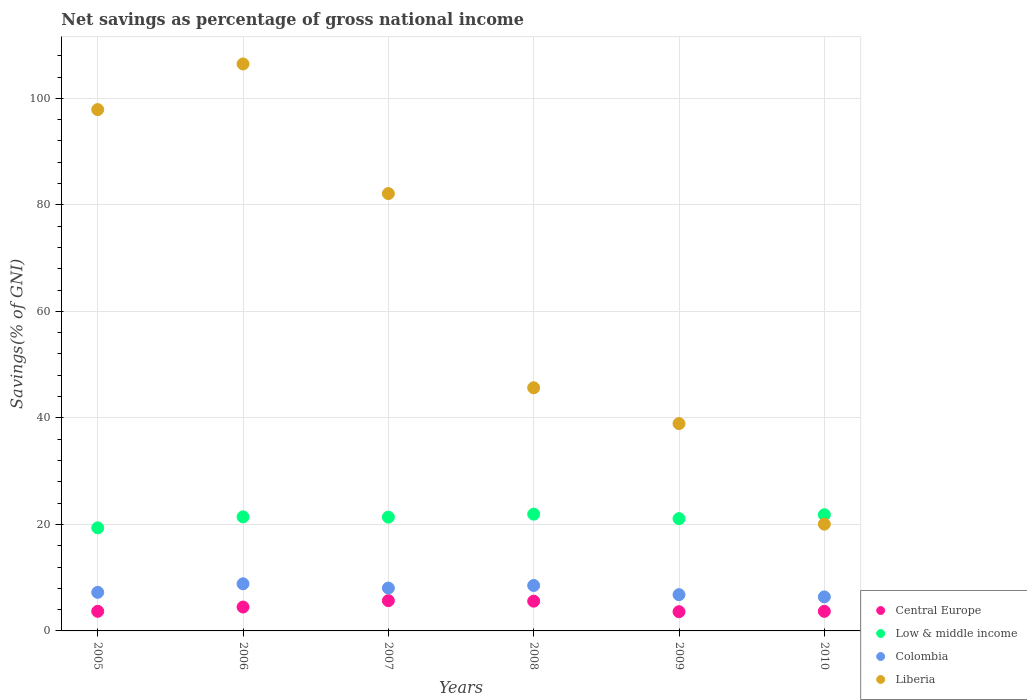Is the number of dotlines equal to the number of legend labels?
Offer a very short reply. Yes. What is the total savings in Liberia in 2010?
Your answer should be very brief. 20.05. Across all years, what is the maximum total savings in Liberia?
Ensure brevity in your answer.  106.46. Across all years, what is the minimum total savings in Low & middle income?
Give a very brief answer. 19.36. What is the total total savings in Liberia in the graph?
Your answer should be compact. 391.12. What is the difference between the total savings in Central Europe in 2005 and that in 2006?
Give a very brief answer. -0.8. What is the difference between the total savings in Central Europe in 2005 and the total savings in Low & middle income in 2009?
Your answer should be compact. -17.4. What is the average total savings in Liberia per year?
Keep it short and to the point. 65.19. In the year 2010, what is the difference between the total savings in Central Europe and total savings in Colombia?
Ensure brevity in your answer.  -2.71. In how many years, is the total savings in Central Europe greater than 56 %?
Make the answer very short. 0. What is the ratio of the total savings in Central Europe in 2005 to that in 2007?
Offer a terse response. 0.65. Is the total savings in Low & middle income in 2007 less than that in 2008?
Offer a very short reply. Yes. Is the difference between the total savings in Central Europe in 2005 and 2009 greater than the difference between the total savings in Colombia in 2005 and 2009?
Keep it short and to the point. No. What is the difference between the highest and the second highest total savings in Central Europe?
Your answer should be very brief. 0.09. What is the difference between the highest and the lowest total savings in Colombia?
Your answer should be compact. 2.46. Is the sum of the total savings in Colombia in 2006 and 2010 greater than the maximum total savings in Central Europe across all years?
Offer a terse response. Yes. Is it the case that in every year, the sum of the total savings in Central Europe and total savings in Colombia  is greater than the total savings in Low & middle income?
Your answer should be very brief. No. What is the difference between two consecutive major ticks on the Y-axis?
Keep it short and to the point. 20. Does the graph contain any zero values?
Make the answer very short. No. How many legend labels are there?
Make the answer very short. 4. How are the legend labels stacked?
Make the answer very short. Vertical. What is the title of the graph?
Your answer should be compact. Net savings as percentage of gross national income. What is the label or title of the X-axis?
Ensure brevity in your answer.  Years. What is the label or title of the Y-axis?
Keep it short and to the point. Savings(% of GNI). What is the Savings(% of GNI) of Central Europe in 2005?
Give a very brief answer. 3.68. What is the Savings(% of GNI) in Low & middle income in 2005?
Provide a short and direct response. 19.36. What is the Savings(% of GNI) of Colombia in 2005?
Provide a short and direct response. 7.24. What is the Savings(% of GNI) of Liberia in 2005?
Give a very brief answer. 97.89. What is the Savings(% of GNI) in Central Europe in 2006?
Provide a short and direct response. 4.48. What is the Savings(% of GNI) in Low & middle income in 2006?
Offer a very short reply. 21.42. What is the Savings(% of GNI) of Colombia in 2006?
Offer a very short reply. 8.85. What is the Savings(% of GNI) in Liberia in 2006?
Make the answer very short. 106.46. What is the Savings(% of GNI) of Central Europe in 2007?
Your answer should be very brief. 5.68. What is the Savings(% of GNI) of Low & middle income in 2007?
Make the answer very short. 21.36. What is the Savings(% of GNI) in Colombia in 2007?
Your answer should be very brief. 8.05. What is the Savings(% of GNI) in Liberia in 2007?
Make the answer very short. 82.12. What is the Savings(% of GNI) of Central Europe in 2008?
Keep it short and to the point. 5.59. What is the Savings(% of GNI) in Low & middle income in 2008?
Your answer should be very brief. 21.93. What is the Savings(% of GNI) in Colombia in 2008?
Ensure brevity in your answer.  8.53. What is the Savings(% of GNI) in Liberia in 2008?
Ensure brevity in your answer.  45.66. What is the Savings(% of GNI) of Central Europe in 2009?
Your answer should be very brief. 3.61. What is the Savings(% of GNI) of Low & middle income in 2009?
Keep it short and to the point. 21.09. What is the Savings(% of GNI) of Colombia in 2009?
Ensure brevity in your answer.  6.81. What is the Savings(% of GNI) in Liberia in 2009?
Provide a succinct answer. 38.93. What is the Savings(% of GNI) in Central Europe in 2010?
Offer a terse response. 3.68. What is the Savings(% of GNI) of Low & middle income in 2010?
Offer a terse response. 21.82. What is the Savings(% of GNI) of Colombia in 2010?
Your answer should be compact. 6.39. What is the Savings(% of GNI) of Liberia in 2010?
Ensure brevity in your answer.  20.05. Across all years, what is the maximum Savings(% of GNI) of Central Europe?
Provide a succinct answer. 5.68. Across all years, what is the maximum Savings(% of GNI) in Low & middle income?
Offer a terse response. 21.93. Across all years, what is the maximum Savings(% of GNI) of Colombia?
Your answer should be compact. 8.85. Across all years, what is the maximum Savings(% of GNI) of Liberia?
Offer a terse response. 106.46. Across all years, what is the minimum Savings(% of GNI) of Central Europe?
Provide a short and direct response. 3.61. Across all years, what is the minimum Savings(% of GNI) in Low & middle income?
Ensure brevity in your answer.  19.36. Across all years, what is the minimum Savings(% of GNI) of Colombia?
Provide a succinct answer. 6.39. Across all years, what is the minimum Savings(% of GNI) in Liberia?
Give a very brief answer. 20.05. What is the total Savings(% of GNI) of Central Europe in the graph?
Make the answer very short. 26.72. What is the total Savings(% of GNI) of Low & middle income in the graph?
Offer a very short reply. 126.96. What is the total Savings(% of GNI) in Colombia in the graph?
Make the answer very short. 45.87. What is the total Savings(% of GNI) of Liberia in the graph?
Provide a succinct answer. 391.12. What is the difference between the Savings(% of GNI) in Central Europe in 2005 and that in 2006?
Keep it short and to the point. -0.8. What is the difference between the Savings(% of GNI) of Low & middle income in 2005 and that in 2006?
Provide a succinct answer. -2.06. What is the difference between the Savings(% of GNI) of Colombia in 2005 and that in 2006?
Make the answer very short. -1.61. What is the difference between the Savings(% of GNI) in Liberia in 2005 and that in 2006?
Make the answer very short. -8.57. What is the difference between the Savings(% of GNI) of Central Europe in 2005 and that in 2007?
Offer a terse response. -2. What is the difference between the Savings(% of GNI) in Low & middle income in 2005 and that in 2007?
Offer a terse response. -2.01. What is the difference between the Savings(% of GNI) of Colombia in 2005 and that in 2007?
Ensure brevity in your answer.  -0.8. What is the difference between the Savings(% of GNI) of Liberia in 2005 and that in 2007?
Your answer should be very brief. 15.77. What is the difference between the Savings(% of GNI) in Central Europe in 2005 and that in 2008?
Provide a short and direct response. -1.9. What is the difference between the Savings(% of GNI) in Low & middle income in 2005 and that in 2008?
Make the answer very short. -2.57. What is the difference between the Savings(% of GNI) of Colombia in 2005 and that in 2008?
Offer a terse response. -1.29. What is the difference between the Savings(% of GNI) of Liberia in 2005 and that in 2008?
Give a very brief answer. 52.24. What is the difference between the Savings(% of GNI) in Central Europe in 2005 and that in 2009?
Offer a very short reply. 0.07. What is the difference between the Savings(% of GNI) of Low & middle income in 2005 and that in 2009?
Your answer should be compact. -1.73. What is the difference between the Savings(% of GNI) of Colombia in 2005 and that in 2009?
Provide a short and direct response. 0.43. What is the difference between the Savings(% of GNI) in Liberia in 2005 and that in 2009?
Your answer should be compact. 58.96. What is the difference between the Savings(% of GNI) in Central Europe in 2005 and that in 2010?
Provide a succinct answer. 0. What is the difference between the Savings(% of GNI) in Low & middle income in 2005 and that in 2010?
Ensure brevity in your answer.  -2.46. What is the difference between the Savings(% of GNI) of Colombia in 2005 and that in 2010?
Offer a terse response. 0.85. What is the difference between the Savings(% of GNI) in Liberia in 2005 and that in 2010?
Provide a succinct answer. 77.84. What is the difference between the Savings(% of GNI) in Central Europe in 2006 and that in 2007?
Offer a terse response. -1.2. What is the difference between the Savings(% of GNI) of Low & middle income in 2006 and that in 2007?
Offer a very short reply. 0.05. What is the difference between the Savings(% of GNI) in Colombia in 2006 and that in 2007?
Make the answer very short. 0.8. What is the difference between the Savings(% of GNI) of Liberia in 2006 and that in 2007?
Your answer should be compact. 24.34. What is the difference between the Savings(% of GNI) of Central Europe in 2006 and that in 2008?
Provide a succinct answer. -1.1. What is the difference between the Savings(% of GNI) in Low & middle income in 2006 and that in 2008?
Provide a succinct answer. -0.51. What is the difference between the Savings(% of GNI) in Colombia in 2006 and that in 2008?
Your answer should be compact. 0.31. What is the difference between the Savings(% of GNI) in Liberia in 2006 and that in 2008?
Provide a short and direct response. 60.81. What is the difference between the Savings(% of GNI) in Central Europe in 2006 and that in 2009?
Offer a terse response. 0.88. What is the difference between the Savings(% of GNI) in Low & middle income in 2006 and that in 2009?
Your answer should be very brief. 0.33. What is the difference between the Savings(% of GNI) in Colombia in 2006 and that in 2009?
Make the answer very short. 2.04. What is the difference between the Savings(% of GNI) of Liberia in 2006 and that in 2009?
Make the answer very short. 67.53. What is the difference between the Savings(% of GNI) of Central Europe in 2006 and that in 2010?
Offer a terse response. 0.81. What is the difference between the Savings(% of GNI) of Low & middle income in 2006 and that in 2010?
Your answer should be very brief. -0.4. What is the difference between the Savings(% of GNI) of Colombia in 2006 and that in 2010?
Provide a succinct answer. 2.46. What is the difference between the Savings(% of GNI) in Liberia in 2006 and that in 2010?
Your response must be concise. 86.41. What is the difference between the Savings(% of GNI) in Central Europe in 2007 and that in 2008?
Offer a very short reply. 0.09. What is the difference between the Savings(% of GNI) in Low & middle income in 2007 and that in 2008?
Provide a succinct answer. -0.56. What is the difference between the Savings(% of GNI) in Colombia in 2007 and that in 2008?
Make the answer very short. -0.49. What is the difference between the Savings(% of GNI) of Liberia in 2007 and that in 2008?
Keep it short and to the point. 36.46. What is the difference between the Savings(% of GNI) of Central Europe in 2007 and that in 2009?
Your response must be concise. 2.07. What is the difference between the Savings(% of GNI) of Low & middle income in 2007 and that in 2009?
Your answer should be very brief. 0.28. What is the difference between the Savings(% of GNI) in Colombia in 2007 and that in 2009?
Your answer should be very brief. 1.24. What is the difference between the Savings(% of GNI) in Liberia in 2007 and that in 2009?
Make the answer very short. 43.19. What is the difference between the Savings(% of GNI) in Central Europe in 2007 and that in 2010?
Provide a succinct answer. 2. What is the difference between the Savings(% of GNI) in Low & middle income in 2007 and that in 2010?
Make the answer very short. -0.45. What is the difference between the Savings(% of GNI) in Colombia in 2007 and that in 2010?
Make the answer very short. 1.66. What is the difference between the Savings(% of GNI) of Liberia in 2007 and that in 2010?
Provide a short and direct response. 62.07. What is the difference between the Savings(% of GNI) in Central Europe in 2008 and that in 2009?
Keep it short and to the point. 1.98. What is the difference between the Savings(% of GNI) in Low & middle income in 2008 and that in 2009?
Keep it short and to the point. 0.84. What is the difference between the Savings(% of GNI) of Colombia in 2008 and that in 2009?
Your answer should be very brief. 1.73. What is the difference between the Savings(% of GNI) in Liberia in 2008 and that in 2009?
Offer a terse response. 6.73. What is the difference between the Savings(% of GNI) in Central Europe in 2008 and that in 2010?
Ensure brevity in your answer.  1.91. What is the difference between the Savings(% of GNI) of Low & middle income in 2008 and that in 2010?
Offer a very short reply. 0.11. What is the difference between the Savings(% of GNI) in Colombia in 2008 and that in 2010?
Your answer should be compact. 2.14. What is the difference between the Savings(% of GNI) of Liberia in 2008 and that in 2010?
Give a very brief answer. 25.61. What is the difference between the Savings(% of GNI) in Central Europe in 2009 and that in 2010?
Provide a succinct answer. -0.07. What is the difference between the Savings(% of GNI) of Low & middle income in 2009 and that in 2010?
Your answer should be compact. -0.73. What is the difference between the Savings(% of GNI) of Colombia in 2009 and that in 2010?
Offer a terse response. 0.42. What is the difference between the Savings(% of GNI) of Liberia in 2009 and that in 2010?
Make the answer very short. 18.88. What is the difference between the Savings(% of GNI) in Central Europe in 2005 and the Savings(% of GNI) in Low & middle income in 2006?
Provide a succinct answer. -17.74. What is the difference between the Savings(% of GNI) in Central Europe in 2005 and the Savings(% of GNI) in Colombia in 2006?
Ensure brevity in your answer.  -5.17. What is the difference between the Savings(% of GNI) of Central Europe in 2005 and the Savings(% of GNI) of Liberia in 2006?
Offer a very short reply. -102.78. What is the difference between the Savings(% of GNI) in Low & middle income in 2005 and the Savings(% of GNI) in Colombia in 2006?
Offer a very short reply. 10.51. What is the difference between the Savings(% of GNI) in Low & middle income in 2005 and the Savings(% of GNI) in Liberia in 2006?
Give a very brief answer. -87.11. What is the difference between the Savings(% of GNI) of Colombia in 2005 and the Savings(% of GNI) of Liberia in 2006?
Provide a succinct answer. -99.22. What is the difference between the Savings(% of GNI) in Central Europe in 2005 and the Savings(% of GNI) in Low & middle income in 2007?
Offer a terse response. -17.68. What is the difference between the Savings(% of GNI) in Central Europe in 2005 and the Savings(% of GNI) in Colombia in 2007?
Give a very brief answer. -4.37. What is the difference between the Savings(% of GNI) of Central Europe in 2005 and the Savings(% of GNI) of Liberia in 2007?
Offer a very short reply. -78.44. What is the difference between the Savings(% of GNI) in Low & middle income in 2005 and the Savings(% of GNI) in Colombia in 2007?
Ensure brevity in your answer.  11.31. What is the difference between the Savings(% of GNI) in Low & middle income in 2005 and the Savings(% of GNI) in Liberia in 2007?
Your answer should be very brief. -62.76. What is the difference between the Savings(% of GNI) in Colombia in 2005 and the Savings(% of GNI) in Liberia in 2007?
Offer a terse response. -74.88. What is the difference between the Savings(% of GNI) in Central Europe in 2005 and the Savings(% of GNI) in Low & middle income in 2008?
Give a very brief answer. -18.24. What is the difference between the Savings(% of GNI) in Central Europe in 2005 and the Savings(% of GNI) in Colombia in 2008?
Offer a terse response. -4.85. What is the difference between the Savings(% of GNI) in Central Europe in 2005 and the Savings(% of GNI) in Liberia in 2008?
Provide a short and direct response. -41.98. What is the difference between the Savings(% of GNI) of Low & middle income in 2005 and the Savings(% of GNI) of Colombia in 2008?
Offer a very short reply. 10.82. What is the difference between the Savings(% of GNI) in Low & middle income in 2005 and the Savings(% of GNI) in Liberia in 2008?
Your answer should be very brief. -26.3. What is the difference between the Savings(% of GNI) in Colombia in 2005 and the Savings(% of GNI) in Liberia in 2008?
Offer a terse response. -38.42. What is the difference between the Savings(% of GNI) in Central Europe in 2005 and the Savings(% of GNI) in Low & middle income in 2009?
Offer a very short reply. -17.4. What is the difference between the Savings(% of GNI) of Central Europe in 2005 and the Savings(% of GNI) of Colombia in 2009?
Your answer should be very brief. -3.13. What is the difference between the Savings(% of GNI) of Central Europe in 2005 and the Savings(% of GNI) of Liberia in 2009?
Make the answer very short. -35.25. What is the difference between the Savings(% of GNI) in Low & middle income in 2005 and the Savings(% of GNI) in Colombia in 2009?
Offer a terse response. 12.55. What is the difference between the Savings(% of GNI) in Low & middle income in 2005 and the Savings(% of GNI) in Liberia in 2009?
Provide a succinct answer. -19.58. What is the difference between the Savings(% of GNI) of Colombia in 2005 and the Savings(% of GNI) of Liberia in 2009?
Provide a succinct answer. -31.69. What is the difference between the Savings(% of GNI) in Central Europe in 2005 and the Savings(% of GNI) in Low & middle income in 2010?
Give a very brief answer. -18.14. What is the difference between the Savings(% of GNI) in Central Europe in 2005 and the Savings(% of GNI) in Colombia in 2010?
Make the answer very short. -2.71. What is the difference between the Savings(% of GNI) in Central Europe in 2005 and the Savings(% of GNI) in Liberia in 2010?
Your answer should be compact. -16.37. What is the difference between the Savings(% of GNI) in Low & middle income in 2005 and the Savings(% of GNI) in Colombia in 2010?
Your answer should be very brief. 12.97. What is the difference between the Savings(% of GNI) of Low & middle income in 2005 and the Savings(% of GNI) of Liberia in 2010?
Provide a succinct answer. -0.69. What is the difference between the Savings(% of GNI) in Colombia in 2005 and the Savings(% of GNI) in Liberia in 2010?
Keep it short and to the point. -12.81. What is the difference between the Savings(% of GNI) of Central Europe in 2006 and the Savings(% of GNI) of Low & middle income in 2007?
Your response must be concise. -16.88. What is the difference between the Savings(% of GNI) of Central Europe in 2006 and the Savings(% of GNI) of Colombia in 2007?
Keep it short and to the point. -3.56. What is the difference between the Savings(% of GNI) in Central Europe in 2006 and the Savings(% of GNI) in Liberia in 2007?
Your response must be concise. -77.64. What is the difference between the Savings(% of GNI) in Low & middle income in 2006 and the Savings(% of GNI) in Colombia in 2007?
Offer a very short reply. 13.37. What is the difference between the Savings(% of GNI) in Low & middle income in 2006 and the Savings(% of GNI) in Liberia in 2007?
Give a very brief answer. -60.7. What is the difference between the Savings(% of GNI) of Colombia in 2006 and the Savings(% of GNI) of Liberia in 2007?
Your answer should be very brief. -73.27. What is the difference between the Savings(% of GNI) of Central Europe in 2006 and the Savings(% of GNI) of Low & middle income in 2008?
Offer a very short reply. -17.44. What is the difference between the Savings(% of GNI) of Central Europe in 2006 and the Savings(% of GNI) of Colombia in 2008?
Your answer should be compact. -4.05. What is the difference between the Savings(% of GNI) in Central Europe in 2006 and the Savings(% of GNI) in Liberia in 2008?
Ensure brevity in your answer.  -41.17. What is the difference between the Savings(% of GNI) of Low & middle income in 2006 and the Savings(% of GNI) of Colombia in 2008?
Offer a very short reply. 12.88. What is the difference between the Savings(% of GNI) in Low & middle income in 2006 and the Savings(% of GNI) in Liberia in 2008?
Your response must be concise. -24.24. What is the difference between the Savings(% of GNI) in Colombia in 2006 and the Savings(% of GNI) in Liberia in 2008?
Your response must be concise. -36.81. What is the difference between the Savings(% of GNI) in Central Europe in 2006 and the Savings(% of GNI) in Low & middle income in 2009?
Provide a succinct answer. -16.6. What is the difference between the Savings(% of GNI) in Central Europe in 2006 and the Savings(% of GNI) in Colombia in 2009?
Your response must be concise. -2.32. What is the difference between the Savings(% of GNI) in Central Europe in 2006 and the Savings(% of GNI) in Liberia in 2009?
Give a very brief answer. -34.45. What is the difference between the Savings(% of GNI) of Low & middle income in 2006 and the Savings(% of GNI) of Colombia in 2009?
Offer a very short reply. 14.61. What is the difference between the Savings(% of GNI) of Low & middle income in 2006 and the Savings(% of GNI) of Liberia in 2009?
Make the answer very short. -17.51. What is the difference between the Savings(% of GNI) in Colombia in 2006 and the Savings(% of GNI) in Liberia in 2009?
Your answer should be compact. -30.08. What is the difference between the Savings(% of GNI) in Central Europe in 2006 and the Savings(% of GNI) in Low & middle income in 2010?
Ensure brevity in your answer.  -17.33. What is the difference between the Savings(% of GNI) in Central Europe in 2006 and the Savings(% of GNI) in Colombia in 2010?
Ensure brevity in your answer.  -1.91. What is the difference between the Savings(% of GNI) in Central Europe in 2006 and the Savings(% of GNI) in Liberia in 2010?
Provide a succinct answer. -15.57. What is the difference between the Savings(% of GNI) of Low & middle income in 2006 and the Savings(% of GNI) of Colombia in 2010?
Ensure brevity in your answer.  15.03. What is the difference between the Savings(% of GNI) in Low & middle income in 2006 and the Savings(% of GNI) in Liberia in 2010?
Keep it short and to the point. 1.37. What is the difference between the Savings(% of GNI) of Colombia in 2006 and the Savings(% of GNI) of Liberia in 2010?
Offer a very short reply. -11.2. What is the difference between the Savings(% of GNI) in Central Europe in 2007 and the Savings(% of GNI) in Low & middle income in 2008?
Ensure brevity in your answer.  -16.24. What is the difference between the Savings(% of GNI) of Central Europe in 2007 and the Savings(% of GNI) of Colombia in 2008?
Your response must be concise. -2.85. What is the difference between the Savings(% of GNI) in Central Europe in 2007 and the Savings(% of GNI) in Liberia in 2008?
Offer a terse response. -39.98. What is the difference between the Savings(% of GNI) in Low & middle income in 2007 and the Savings(% of GNI) in Colombia in 2008?
Your answer should be very brief. 12.83. What is the difference between the Savings(% of GNI) of Low & middle income in 2007 and the Savings(% of GNI) of Liberia in 2008?
Ensure brevity in your answer.  -24.29. What is the difference between the Savings(% of GNI) in Colombia in 2007 and the Savings(% of GNI) in Liberia in 2008?
Ensure brevity in your answer.  -37.61. What is the difference between the Savings(% of GNI) of Central Europe in 2007 and the Savings(% of GNI) of Low & middle income in 2009?
Keep it short and to the point. -15.4. What is the difference between the Savings(% of GNI) in Central Europe in 2007 and the Savings(% of GNI) in Colombia in 2009?
Ensure brevity in your answer.  -1.13. What is the difference between the Savings(% of GNI) of Central Europe in 2007 and the Savings(% of GNI) of Liberia in 2009?
Your response must be concise. -33.25. What is the difference between the Savings(% of GNI) in Low & middle income in 2007 and the Savings(% of GNI) in Colombia in 2009?
Offer a terse response. 14.56. What is the difference between the Savings(% of GNI) in Low & middle income in 2007 and the Savings(% of GNI) in Liberia in 2009?
Provide a succinct answer. -17.57. What is the difference between the Savings(% of GNI) in Colombia in 2007 and the Savings(% of GNI) in Liberia in 2009?
Your answer should be very brief. -30.89. What is the difference between the Savings(% of GNI) in Central Europe in 2007 and the Savings(% of GNI) in Low & middle income in 2010?
Ensure brevity in your answer.  -16.14. What is the difference between the Savings(% of GNI) in Central Europe in 2007 and the Savings(% of GNI) in Colombia in 2010?
Give a very brief answer. -0.71. What is the difference between the Savings(% of GNI) in Central Europe in 2007 and the Savings(% of GNI) in Liberia in 2010?
Offer a terse response. -14.37. What is the difference between the Savings(% of GNI) of Low & middle income in 2007 and the Savings(% of GNI) of Colombia in 2010?
Make the answer very short. 14.97. What is the difference between the Savings(% of GNI) of Low & middle income in 2007 and the Savings(% of GNI) of Liberia in 2010?
Your answer should be very brief. 1.31. What is the difference between the Savings(% of GNI) of Colombia in 2007 and the Savings(% of GNI) of Liberia in 2010?
Your answer should be compact. -12. What is the difference between the Savings(% of GNI) in Central Europe in 2008 and the Savings(% of GNI) in Low & middle income in 2009?
Offer a terse response. -15.5. What is the difference between the Savings(% of GNI) of Central Europe in 2008 and the Savings(% of GNI) of Colombia in 2009?
Provide a short and direct response. -1.22. What is the difference between the Savings(% of GNI) in Central Europe in 2008 and the Savings(% of GNI) in Liberia in 2009?
Offer a terse response. -33.35. What is the difference between the Savings(% of GNI) of Low & middle income in 2008 and the Savings(% of GNI) of Colombia in 2009?
Ensure brevity in your answer.  15.12. What is the difference between the Savings(% of GNI) of Low & middle income in 2008 and the Savings(% of GNI) of Liberia in 2009?
Your answer should be very brief. -17.01. What is the difference between the Savings(% of GNI) of Colombia in 2008 and the Savings(% of GNI) of Liberia in 2009?
Your answer should be very brief. -30.4. What is the difference between the Savings(% of GNI) in Central Europe in 2008 and the Savings(% of GNI) in Low & middle income in 2010?
Your response must be concise. -16.23. What is the difference between the Savings(% of GNI) of Central Europe in 2008 and the Savings(% of GNI) of Colombia in 2010?
Your answer should be very brief. -0.81. What is the difference between the Savings(% of GNI) in Central Europe in 2008 and the Savings(% of GNI) in Liberia in 2010?
Offer a terse response. -14.46. What is the difference between the Savings(% of GNI) in Low & middle income in 2008 and the Savings(% of GNI) in Colombia in 2010?
Provide a succinct answer. 15.53. What is the difference between the Savings(% of GNI) of Low & middle income in 2008 and the Savings(% of GNI) of Liberia in 2010?
Provide a succinct answer. 1.87. What is the difference between the Savings(% of GNI) of Colombia in 2008 and the Savings(% of GNI) of Liberia in 2010?
Ensure brevity in your answer.  -11.52. What is the difference between the Savings(% of GNI) of Central Europe in 2009 and the Savings(% of GNI) of Low & middle income in 2010?
Offer a very short reply. -18.21. What is the difference between the Savings(% of GNI) in Central Europe in 2009 and the Savings(% of GNI) in Colombia in 2010?
Offer a very short reply. -2.78. What is the difference between the Savings(% of GNI) in Central Europe in 2009 and the Savings(% of GNI) in Liberia in 2010?
Ensure brevity in your answer.  -16.44. What is the difference between the Savings(% of GNI) of Low & middle income in 2009 and the Savings(% of GNI) of Colombia in 2010?
Ensure brevity in your answer.  14.69. What is the difference between the Savings(% of GNI) in Low & middle income in 2009 and the Savings(% of GNI) in Liberia in 2010?
Ensure brevity in your answer.  1.03. What is the difference between the Savings(% of GNI) of Colombia in 2009 and the Savings(% of GNI) of Liberia in 2010?
Your response must be concise. -13.24. What is the average Savings(% of GNI) in Central Europe per year?
Make the answer very short. 4.45. What is the average Savings(% of GNI) of Low & middle income per year?
Your answer should be very brief. 21.16. What is the average Savings(% of GNI) in Colombia per year?
Provide a succinct answer. 7.64. What is the average Savings(% of GNI) in Liberia per year?
Offer a very short reply. 65.19. In the year 2005, what is the difference between the Savings(% of GNI) in Central Europe and Savings(% of GNI) in Low & middle income?
Make the answer very short. -15.68. In the year 2005, what is the difference between the Savings(% of GNI) of Central Europe and Savings(% of GNI) of Colombia?
Ensure brevity in your answer.  -3.56. In the year 2005, what is the difference between the Savings(% of GNI) of Central Europe and Savings(% of GNI) of Liberia?
Give a very brief answer. -94.21. In the year 2005, what is the difference between the Savings(% of GNI) of Low & middle income and Savings(% of GNI) of Colombia?
Ensure brevity in your answer.  12.11. In the year 2005, what is the difference between the Savings(% of GNI) of Low & middle income and Savings(% of GNI) of Liberia?
Your response must be concise. -78.54. In the year 2005, what is the difference between the Savings(% of GNI) in Colombia and Savings(% of GNI) in Liberia?
Your answer should be compact. -90.65. In the year 2006, what is the difference between the Savings(% of GNI) in Central Europe and Savings(% of GNI) in Low & middle income?
Your answer should be very brief. -16.93. In the year 2006, what is the difference between the Savings(% of GNI) in Central Europe and Savings(% of GNI) in Colombia?
Provide a short and direct response. -4.36. In the year 2006, what is the difference between the Savings(% of GNI) in Central Europe and Savings(% of GNI) in Liberia?
Make the answer very short. -101.98. In the year 2006, what is the difference between the Savings(% of GNI) of Low & middle income and Savings(% of GNI) of Colombia?
Ensure brevity in your answer.  12.57. In the year 2006, what is the difference between the Savings(% of GNI) in Low & middle income and Savings(% of GNI) in Liberia?
Ensure brevity in your answer.  -85.05. In the year 2006, what is the difference between the Savings(% of GNI) in Colombia and Savings(% of GNI) in Liberia?
Give a very brief answer. -97.61. In the year 2007, what is the difference between the Savings(% of GNI) of Central Europe and Savings(% of GNI) of Low & middle income?
Offer a very short reply. -15.68. In the year 2007, what is the difference between the Savings(% of GNI) in Central Europe and Savings(% of GNI) in Colombia?
Offer a very short reply. -2.37. In the year 2007, what is the difference between the Savings(% of GNI) in Central Europe and Savings(% of GNI) in Liberia?
Give a very brief answer. -76.44. In the year 2007, what is the difference between the Savings(% of GNI) in Low & middle income and Savings(% of GNI) in Colombia?
Offer a terse response. 13.32. In the year 2007, what is the difference between the Savings(% of GNI) in Low & middle income and Savings(% of GNI) in Liberia?
Ensure brevity in your answer.  -60.76. In the year 2007, what is the difference between the Savings(% of GNI) in Colombia and Savings(% of GNI) in Liberia?
Give a very brief answer. -74.07. In the year 2008, what is the difference between the Savings(% of GNI) in Central Europe and Savings(% of GNI) in Low & middle income?
Your answer should be very brief. -16.34. In the year 2008, what is the difference between the Savings(% of GNI) in Central Europe and Savings(% of GNI) in Colombia?
Keep it short and to the point. -2.95. In the year 2008, what is the difference between the Savings(% of GNI) of Central Europe and Savings(% of GNI) of Liberia?
Keep it short and to the point. -40.07. In the year 2008, what is the difference between the Savings(% of GNI) of Low & middle income and Savings(% of GNI) of Colombia?
Keep it short and to the point. 13.39. In the year 2008, what is the difference between the Savings(% of GNI) in Low & middle income and Savings(% of GNI) in Liberia?
Provide a short and direct response. -23.73. In the year 2008, what is the difference between the Savings(% of GNI) in Colombia and Savings(% of GNI) in Liberia?
Your response must be concise. -37.12. In the year 2009, what is the difference between the Savings(% of GNI) in Central Europe and Savings(% of GNI) in Low & middle income?
Your response must be concise. -17.48. In the year 2009, what is the difference between the Savings(% of GNI) in Central Europe and Savings(% of GNI) in Colombia?
Offer a terse response. -3.2. In the year 2009, what is the difference between the Savings(% of GNI) of Central Europe and Savings(% of GNI) of Liberia?
Make the answer very short. -35.32. In the year 2009, what is the difference between the Savings(% of GNI) of Low & middle income and Savings(% of GNI) of Colombia?
Your response must be concise. 14.28. In the year 2009, what is the difference between the Savings(% of GNI) in Low & middle income and Savings(% of GNI) in Liberia?
Ensure brevity in your answer.  -17.85. In the year 2009, what is the difference between the Savings(% of GNI) in Colombia and Savings(% of GNI) in Liberia?
Provide a short and direct response. -32.12. In the year 2010, what is the difference between the Savings(% of GNI) in Central Europe and Savings(% of GNI) in Low & middle income?
Ensure brevity in your answer.  -18.14. In the year 2010, what is the difference between the Savings(% of GNI) of Central Europe and Savings(% of GNI) of Colombia?
Make the answer very short. -2.71. In the year 2010, what is the difference between the Savings(% of GNI) in Central Europe and Savings(% of GNI) in Liberia?
Your answer should be compact. -16.37. In the year 2010, what is the difference between the Savings(% of GNI) in Low & middle income and Savings(% of GNI) in Colombia?
Ensure brevity in your answer.  15.43. In the year 2010, what is the difference between the Savings(% of GNI) of Low & middle income and Savings(% of GNI) of Liberia?
Your answer should be very brief. 1.77. In the year 2010, what is the difference between the Savings(% of GNI) in Colombia and Savings(% of GNI) in Liberia?
Offer a very short reply. -13.66. What is the ratio of the Savings(% of GNI) in Central Europe in 2005 to that in 2006?
Your answer should be compact. 0.82. What is the ratio of the Savings(% of GNI) of Low & middle income in 2005 to that in 2006?
Your response must be concise. 0.9. What is the ratio of the Savings(% of GNI) in Colombia in 2005 to that in 2006?
Make the answer very short. 0.82. What is the ratio of the Savings(% of GNI) in Liberia in 2005 to that in 2006?
Provide a succinct answer. 0.92. What is the ratio of the Savings(% of GNI) of Central Europe in 2005 to that in 2007?
Your answer should be compact. 0.65. What is the ratio of the Savings(% of GNI) in Low & middle income in 2005 to that in 2007?
Your response must be concise. 0.91. What is the ratio of the Savings(% of GNI) of Colombia in 2005 to that in 2007?
Make the answer very short. 0.9. What is the ratio of the Savings(% of GNI) of Liberia in 2005 to that in 2007?
Keep it short and to the point. 1.19. What is the ratio of the Savings(% of GNI) in Central Europe in 2005 to that in 2008?
Offer a very short reply. 0.66. What is the ratio of the Savings(% of GNI) of Low & middle income in 2005 to that in 2008?
Make the answer very short. 0.88. What is the ratio of the Savings(% of GNI) of Colombia in 2005 to that in 2008?
Offer a very short reply. 0.85. What is the ratio of the Savings(% of GNI) in Liberia in 2005 to that in 2008?
Your answer should be very brief. 2.14. What is the ratio of the Savings(% of GNI) in Central Europe in 2005 to that in 2009?
Ensure brevity in your answer.  1.02. What is the ratio of the Savings(% of GNI) in Low & middle income in 2005 to that in 2009?
Offer a very short reply. 0.92. What is the ratio of the Savings(% of GNI) in Colombia in 2005 to that in 2009?
Keep it short and to the point. 1.06. What is the ratio of the Savings(% of GNI) in Liberia in 2005 to that in 2009?
Offer a terse response. 2.51. What is the ratio of the Savings(% of GNI) in Central Europe in 2005 to that in 2010?
Your answer should be very brief. 1. What is the ratio of the Savings(% of GNI) of Low & middle income in 2005 to that in 2010?
Your answer should be very brief. 0.89. What is the ratio of the Savings(% of GNI) in Colombia in 2005 to that in 2010?
Your answer should be compact. 1.13. What is the ratio of the Savings(% of GNI) of Liberia in 2005 to that in 2010?
Your answer should be compact. 4.88. What is the ratio of the Savings(% of GNI) in Central Europe in 2006 to that in 2007?
Offer a terse response. 0.79. What is the ratio of the Savings(% of GNI) of Colombia in 2006 to that in 2007?
Offer a terse response. 1.1. What is the ratio of the Savings(% of GNI) in Liberia in 2006 to that in 2007?
Your answer should be very brief. 1.3. What is the ratio of the Savings(% of GNI) of Central Europe in 2006 to that in 2008?
Provide a succinct answer. 0.8. What is the ratio of the Savings(% of GNI) of Low & middle income in 2006 to that in 2008?
Give a very brief answer. 0.98. What is the ratio of the Savings(% of GNI) in Colombia in 2006 to that in 2008?
Make the answer very short. 1.04. What is the ratio of the Savings(% of GNI) of Liberia in 2006 to that in 2008?
Offer a terse response. 2.33. What is the ratio of the Savings(% of GNI) of Central Europe in 2006 to that in 2009?
Keep it short and to the point. 1.24. What is the ratio of the Savings(% of GNI) of Low & middle income in 2006 to that in 2009?
Keep it short and to the point. 1.02. What is the ratio of the Savings(% of GNI) of Colombia in 2006 to that in 2009?
Your answer should be very brief. 1.3. What is the ratio of the Savings(% of GNI) in Liberia in 2006 to that in 2009?
Your response must be concise. 2.73. What is the ratio of the Savings(% of GNI) of Central Europe in 2006 to that in 2010?
Your response must be concise. 1.22. What is the ratio of the Savings(% of GNI) of Low & middle income in 2006 to that in 2010?
Your answer should be very brief. 0.98. What is the ratio of the Savings(% of GNI) of Colombia in 2006 to that in 2010?
Ensure brevity in your answer.  1.38. What is the ratio of the Savings(% of GNI) in Liberia in 2006 to that in 2010?
Provide a short and direct response. 5.31. What is the ratio of the Savings(% of GNI) of Central Europe in 2007 to that in 2008?
Provide a short and direct response. 1.02. What is the ratio of the Savings(% of GNI) in Low & middle income in 2007 to that in 2008?
Make the answer very short. 0.97. What is the ratio of the Savings(% of GNI) in Colombia in 2007 to that in 2008?
Offer a terse response. 0.94. What is the ratio of the Savings(% of GNI) in Liberia in 2007 to that in 2008?
Provide a succinct answer. 1.8. What is the ratio of the Savings(% of GNI) of Central Europe in 2007 to that in 2009?
Provide a short and direct response. 1.57. What is the ratio of the Savings(% of GNI) in Low & middle income in 2007 to that in 2009?
Give a very brief answer. 1.01. What is the ratio of the Savings(% of GNI) in Colombia in 2007 to that in 2009?
Your answer should be compact. 1.18. What is the ratio of the Savings(% of GNI) of Liberia in 2007 to that in 2009?
Make the answer very short. 2.11. What is the ratio of the Savings(% of GNI) of Central Europe in 2007 to that in 2010?
Ensure brevity in your answer.  1.54. What is the ratio of the Savings(% of GNI) of Low & middle income in 2007 to that in 2010?
Offer a terse response. 0.98. What is the ratio of the Savings(% of GNI) of Colombia in 2007 to that in 2010?
Provide a succinct answer. 1.26. What is the ratio of the Savings(% of GNI) in Liberia in 2007 to that in 2010?
Offer a very short reply. 4.1. What is the ratio of the Savings(% of GNI) of Central Europe in 2008 to that in 2009?
Provide a short and direct response. 1.55. What is the ratio of the Savings(% of GNI) in Low & middle income in 2008 to that in 2009?
Provide a succinct answer. 1.04. What is the ratio of the Savings(% of GNI) of Colombia in 2008 to that in 2009?
Provide a succinct answer. 1.25. What is the ratio of the Savings(% of GNI) in Liberia in 2008 to that in 2009?
Your answer should be very brief. 1.17. What is the ratio of the Savings(% of GNI) of Central Europe in 2008 to that in 2010?
Make the answer very short. 1.52. What is the ratio of the Savings(% of GNI) of Low & middle income in 2008 to that in 2010?
Provide a succinct answer. 1. What is the ratio of the Savings(% of GNI) in Colombia in 2008 to that in 2010?
Offer a very short reply. 1.34. What is the ratio of the Savings(% of GNI) of Liberia in 2008 to that in 2010?
Give a very brief answer. 2.28. What is the ratio of the Savings(% of GNI) of Central Europe in 2009 to that in 2010?
Provide a succinct answer. 0.98. What is the ratio of the Savings(% of GNI) in Low & middle income in 2009 to that in 2010?
Your response must be concise. 0.97. What is the ratio of the Savings(% of GNI) of Colombia in 2009 to that in 2010?
Your answer should be compact. 1.07. What is the ratio of the Savings(% of GNI) of Liberia in 2009 to that in 2010?
Your response must be concise. 1.94. What is the difference between the highest and the second highest Savings(% of GNI) of Central Europe?
Provide a succinct answer. 0.09. What is the difference between the highest and the second highest Savings(% of GNI) of Low & middle income?
Make the answer very short. 0.11. What is the difference between the highest and the second highest Savings(% of GNI) of Colombia?
Your response must be concise. 0.31. What is the difference between the highest and the second highest Savings(% of GNI) in Liberia?
Provide a short and direct response. 8.57. What is the difference between the highest and the lowest Savings(% of GNI) in Central Europe?
Provide a succinct answer. 2.07. What is the difference between the highest and the lowest Savings(% of GNI) in Low & middle income?
Your response must be concise. 2.57. What is the difference between the highest and the lowest Savings(% of GNI) of Colombia?
Provide a short and direct response. 2.46. What is the difference between the highest and the lowest Savings(% of GNI) in Liberia?
Offer a very short reply. 86.41. 